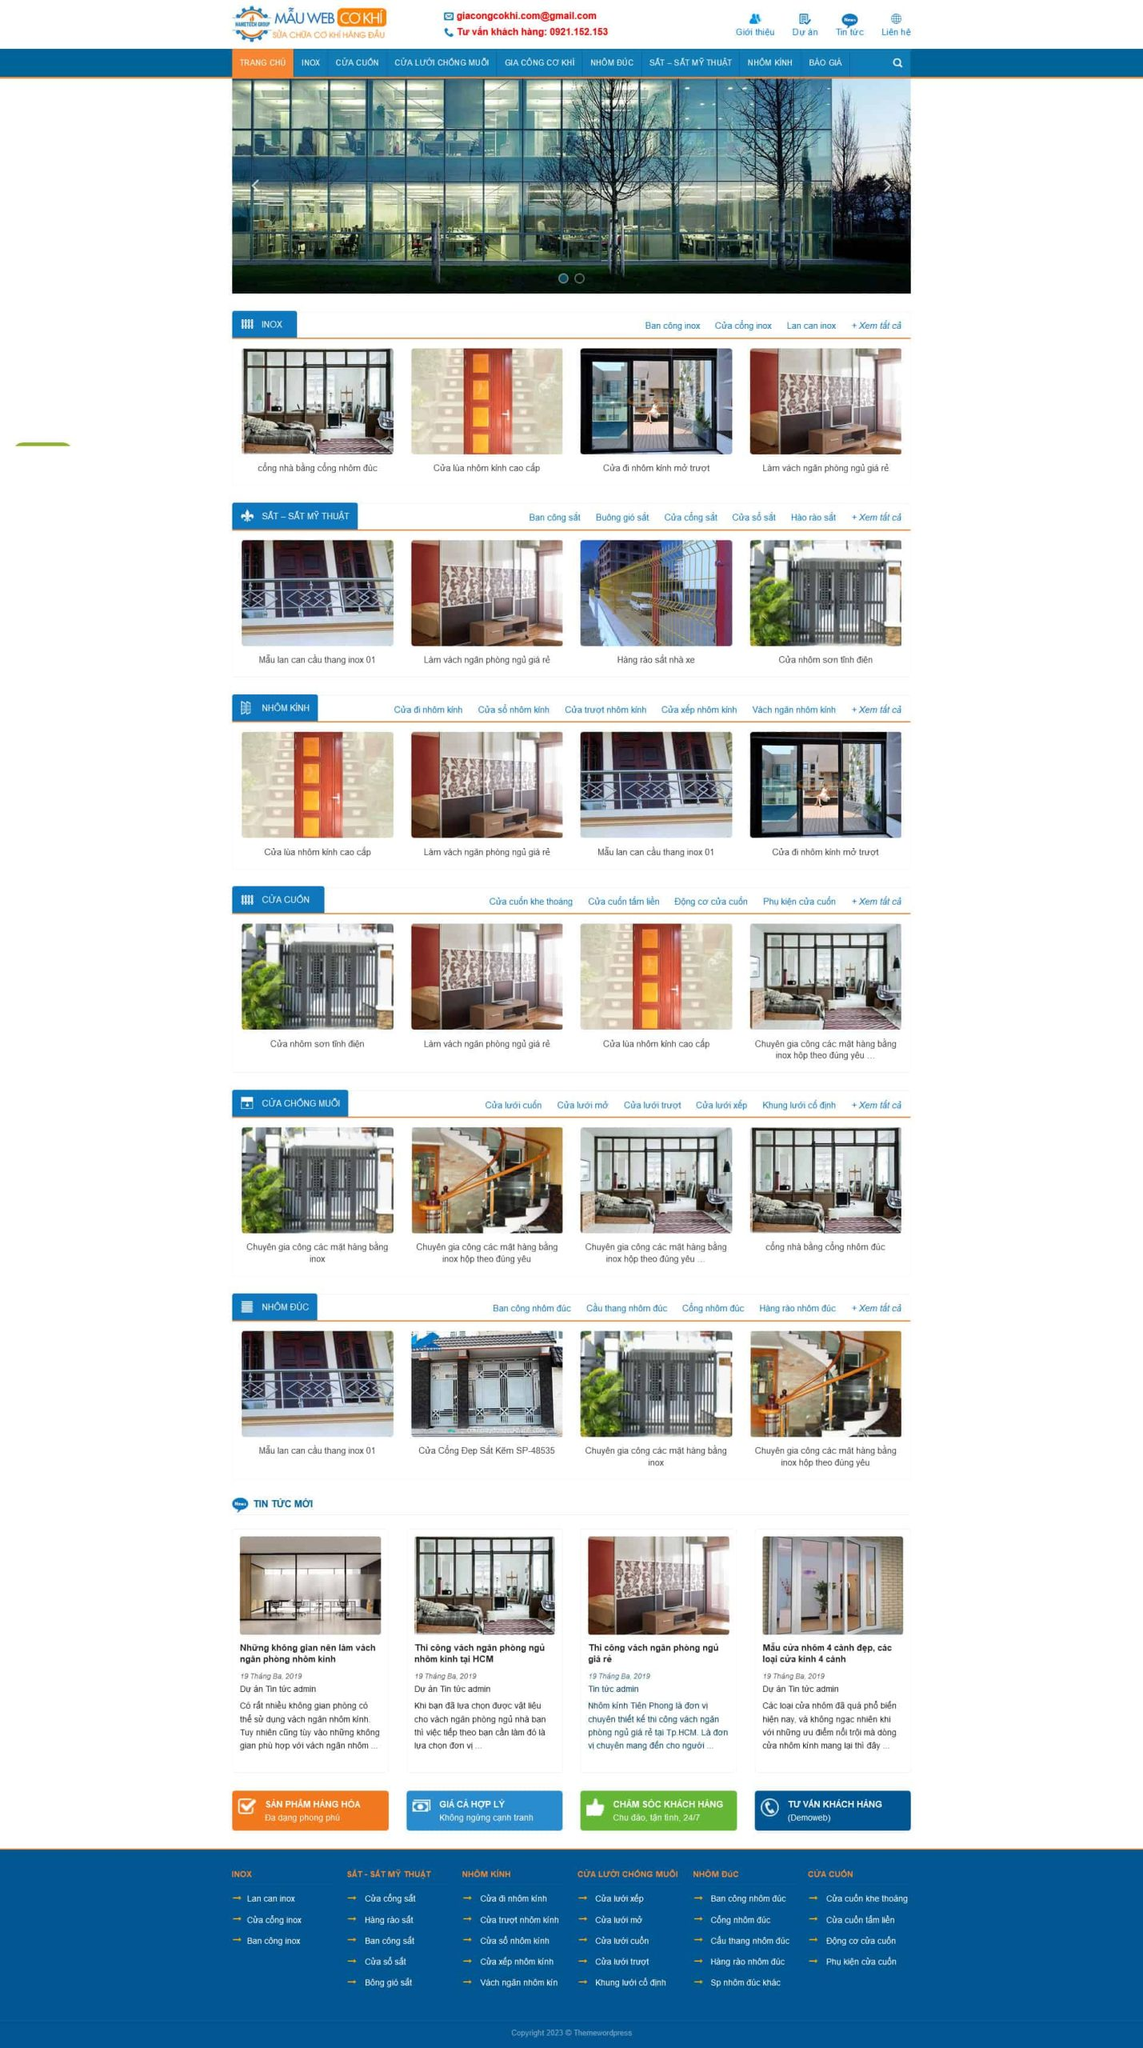Liệt kê 5 ngành nghề, lĩnh vực phù hợp với website này, phân cách các màu sắc bằng dấu phẩy. Chỉ trả về kết quả, phân cách bằng dấy phẩy
 Công nghiệp sản xuất cửa, Công nghiệp sản xuất nhôm kính, Xây dựng và kiến trúc, Nội thất và trang trí nội thất, Sắt mỹ thuật 